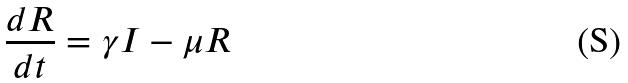<formula> <loc_0><loc_0><loc_500><loc_500>\frac { d R } { d t } = \gamma I - \mu R</formula> 